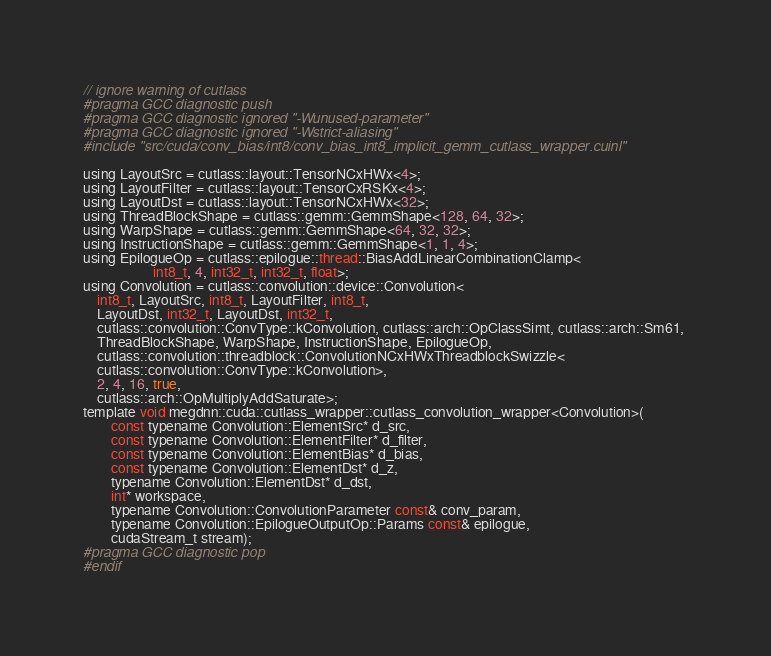<code> <loc_0><loc_0><loc_500><loc_500><_Cuda_>// ignore warning of cutlass
#pragma GCC diagnostic push
#pragma GCC diagnostic ignored "-Wunused-parameter"
#pragma GCC diagnostic ignored "-Wstrict-aliasing"
#include "src/cuda/conv_bias/int8/conv_bias_int8_implicit_gemm_cutlass_wrapper.cuinl"

using LayoutSrc = cutlass::layout::TensorNCxHWx<4>;
using LayoutFilter = cutlass::layout::TensorCxRSKx<4>;
using LayoutDst = cutlass::layout::TensorNCxHWx<32>;
using ThreadBlockShape = cutlass::gemm::GemmShape<128, 64, 32>;
using WarpShape = cutlass::gemm::GemmShape<64, 32, 32>;
using InstructionShape = cutlass::gemm::GemmShape<1, 1, 4>;
using EpilogueOp = cutlass::epilogue::thread::BiasAddLinearCombinationClamp<
                    int8_t, 4, int32_t, int32_t, float>;
using Convolution = cutlass::convolution::device::Convolution<
    int8_t, LayoutSrc, int8_t, LayoutFilter, int8_t, 
    LayoutDst, int32_t, LayoutDst, int32_t, 
    cutlass::convolution::ConvType::kConvolution, cutlass::arch::OpClassSimt, cutlass::arch::Sm61, 
    ThreadBlockShape, WarpShape, InstructionShape, EpilogueOp, 
    cutlass::convolution::threadblock::ConvolutionNCxHWxThreadblockSwizzle<
    cutlass::convolution::ConvType::kConvolution>, 
    2, 4, 16, true, 
    cutlass::arch::OpMultiplyAddSaturate>;
template void megdnn::cuda::cutlass_wrapper::cutlass_convolution_wrapper<Convolution>(
        const typename Convolution::ElementSrc* d_src, 
        const typename Convolution::ElementFilter* d_filter, 
        const typename Convolution::ElementBias* d_bias, 
        const typename Convolution::ElementDst* d_z, 
        typename Convolution::ElementDst* d_dst, 
        int* workspace, 
        typename Convolution::ConvolutionParameter const& conv_param, 
        typename Convolution::EpilogueOutputOp::Params const& epilogue, 
        cudaStream_t stream);
#pragma GCC diagnostic pop
#endif
</code> 